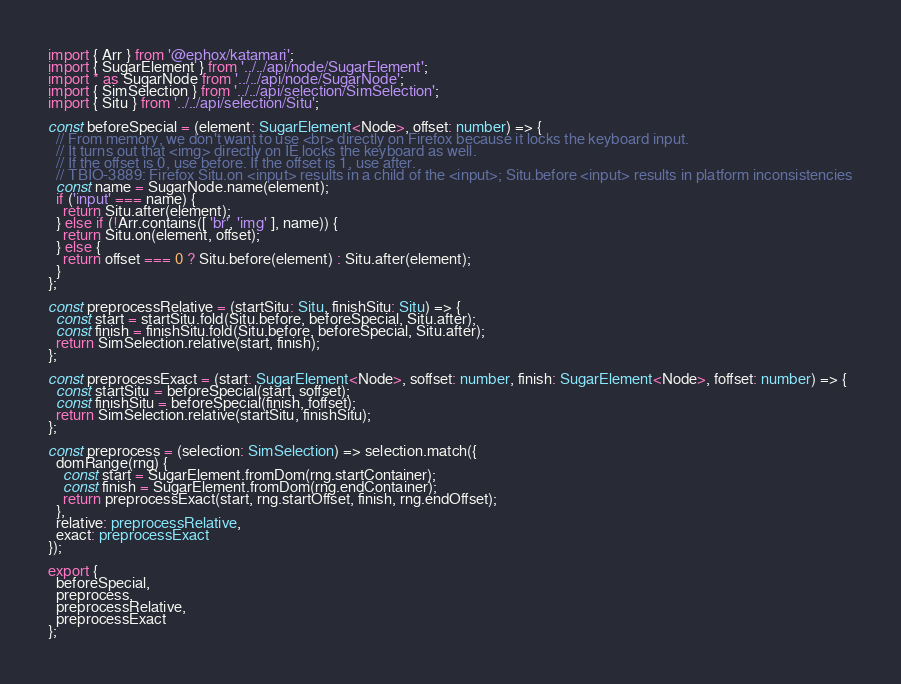<code> <loc_0><loc_0><loc_500><loc_500><_TypeScript_>import { Arr } from '@ephox/katamari';
import { SugarElement } from '../../api/node/SugarElement';
import * as SugarNode from '../../api/node/SugarNode';
import { SimSelection } from '../../api/selection/SimSelection';
import { Situ } from '../../api/selection/Situ';

const beforeSpecial = (element: SugarElement<Node>, offset: number) => {
  // From memory, we don't want to use <br> directly on Firefox because it locks the keyboard input.
  // It turns out that <img> directly on IE locks the keyboard as well.
  // If the offset is 0, use before. If the offset is 1, use after.
  // TBIO-3889: Firefox Situ.on <input> results in a child of the <input>; Situ.before <input> results in platform inconsistencies
  const name = SugarNode.name(element);
  if ('input' === name) {
    return Situ.after(element);
  } else if (!Arr.contains([ 'br', 'img' ], name)) {
    return Situ.on(element, offset);
  } else {
    return offset === 0 ? Situ.before(element) : Situ.after(element);
  }
};

const preprocessRelative = (startSitu: Situ, finishSitu: Situ) => {
  const start = startSitu.fold(Situ.before, beforeSpecial, Situ.after);
  const finish = finishSitu.fold(Situ.before, beforeSpecial, Situ.after);
  return SimSelection.relative(start, finish);
};

const preprocessExact = (start: SugarElement<Node>, soffset: number, finish: SugarElement<Node>, foffset: number) => {
  const startSitu = beforeSpecial(start, soffset);
  const finishSitu = beforeSpecial(finish, foffset);
  return SimSelection.relative(startSitu, finishSitu);
};

const preprocess = (selection: SimSelection) => selection.match({
  domRange(rng) {
    const start = SugarElement.fromDom(rng.startContainer);
    const finish = SugarElement.fromDom(rng.endContainer);
    return preprocessExact(start, rng.startOffset, finish, rng.endOffset);
  },
  relative: preprocessRelative,
  exact: preprocessExact
});

export {
  beforeSpecial,
  preprocess,
  preprocessRelative,
  preprocessExact
};
</code> 